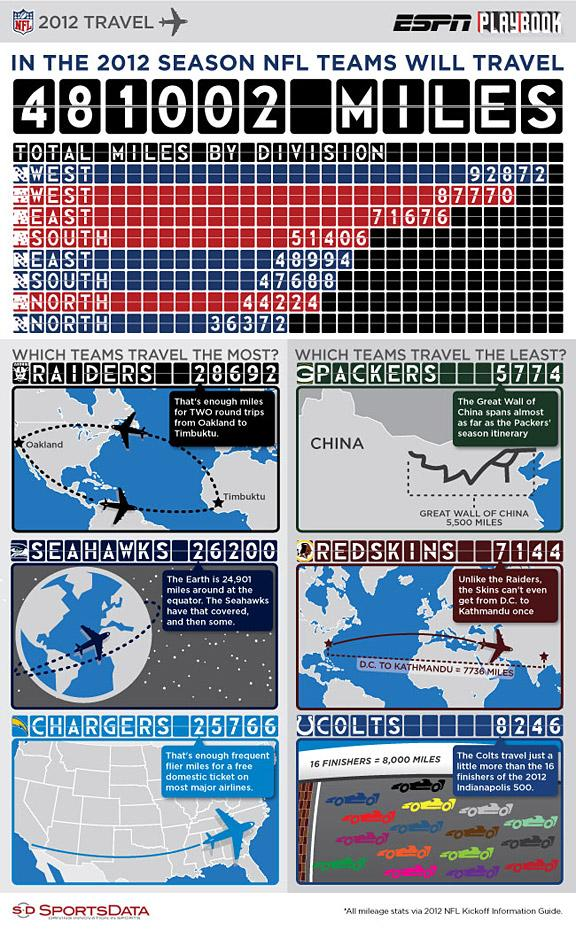Indicate a few pertinent items in this graphic. During the 2012 NFL season, the AFC East teams traveled a total of 71,676 miles. The Green Bay Packers have traveled the least out of all NFL teams during the 2012 season. The NFC North division has traveled the least in the 2012 NFL season. The NFC South teams traveled a total of 47,688 miles during the 2012 NFL season. During the 2012 NFL season, the 'Redskins' travelled a total of 7144 miles. 